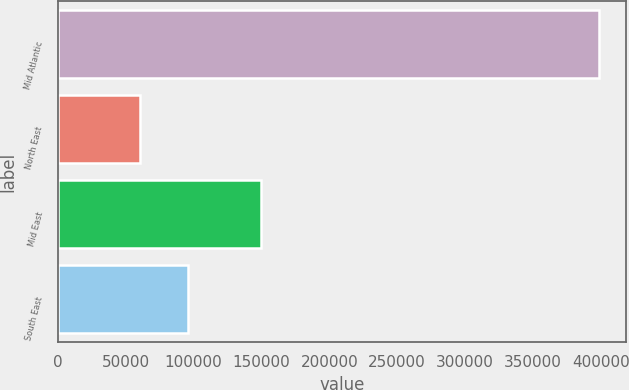<chart> <loc_0><loc_0><loc_500><loc_500><bar_chart><fcel>Mid Atlantic<fcel>North East<fcel>Mid East<fcel>South East<nl><fcel>398494<fcel>60218<fcel>149639<fcel>95826<nl></chart> 